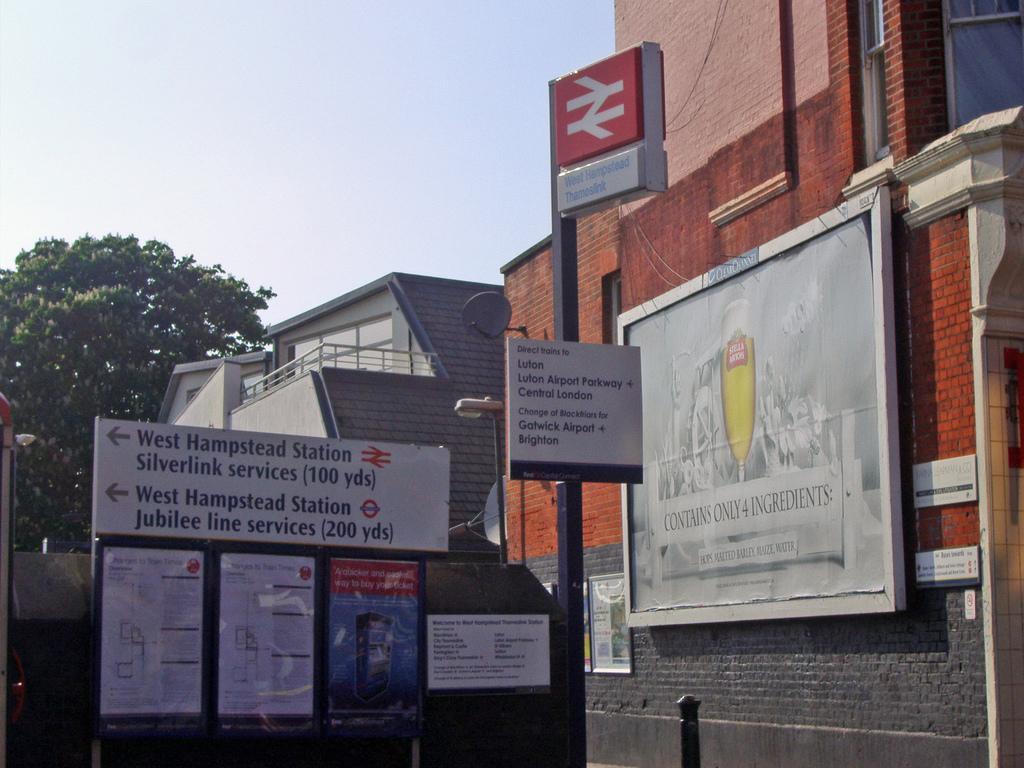How would you summarize this image in a sentence or two? In this picture I can see many buildings and trees. In the center I can see the sign boards, advertisement boards, posters and banners which are placed on the pole and wall. On the left there is a street light. At the top I can see the sky. 